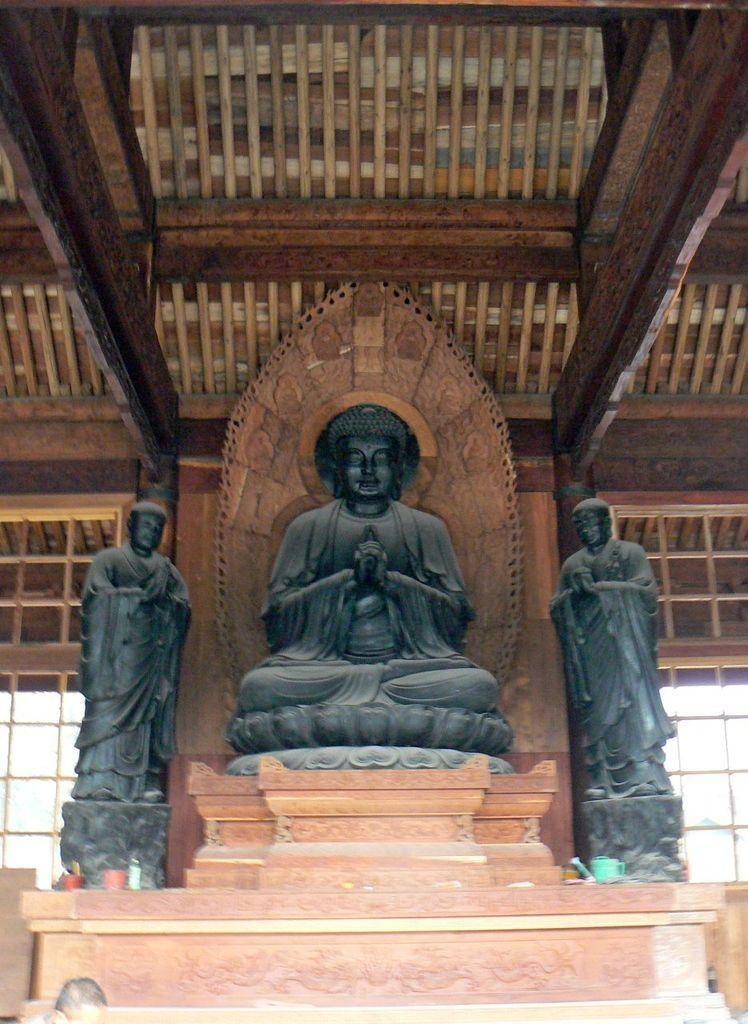What can be seen on the path in the image? There are statues on a path in the image. What is located in front of the statues? There are objects in front of the statues. What is behind the statues in the image? There is a wall behind the statues. What object is associated with the wall? There is an object associated with the wall. What industry is represented by the statues in the image? There is no indication of any industry in the image; it features statues on a path with objects in front and a wall behind. What impulse might have led to the creation of the statues in the image? The image does not provide any information about the motivation or impulse behind the creation of the statues. 